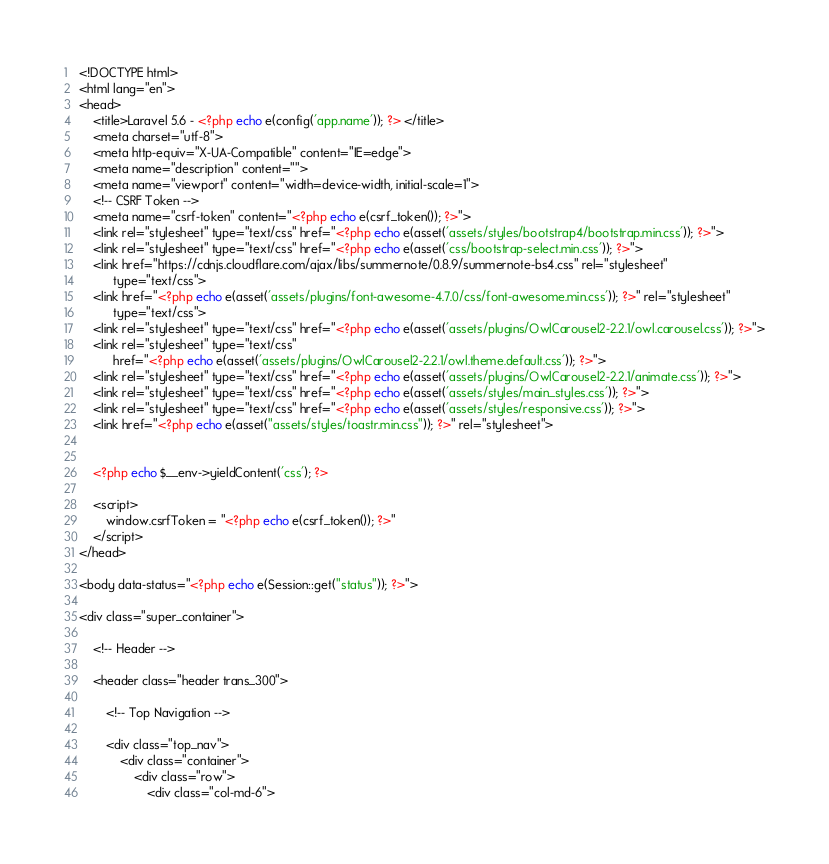<code> <loc_0><loc_0><loc_500><loc_500><_PHP_><!DOCTYPE html>
<html lang="en">
<head>
    <title>Laravel 5.6 - <?php echo e(config('app.name')); ?> </title>
    <meta charset="utf-8">
    <meta http-equiv="X-UA-Compatible" content="IE=edge">
    <meta name="description" content="">
    <meta name="viewport" content="width=device-width, initial-scale=1">
    <!-- CSRF Token -->
    <meta name="csrf-token" content="<?php echo e(csrf_token()); ?>">
    <link rel="stylesheet" type="text/css" href="<?php echo e(asset('assets/styles/bootstrap4/bootstrap.min.css')); ?>">
    <link rel="stylesheet" type="text/css" href="<?php echo e(asset('css/bootstrap-select.min.css')); ?>">
    <link href="https://cdnjs.cloudflare.com/ajax/libs/summernote/0.8.9/summernote-bs4.css" rel="stylesheet"
          type="text/css">
    <link href="<?php echo e(asset('assets/plugins/font-awesome-4.7.0/css/font-awesome.min.css')); ?>" rel="stylesheet"
          type="text/css">
    <link rel="stylesheet" type="text/css" href="<?php echo e(asset('assets/plugins/OwlCarousel2-2.2.1/owl.carousel.css')); ?>">
    <link rel="stylesheet" type="text/css"
          href="<?php echo e(asset('assets/plugins/OwlCarousel2-2.2.1/owl.theme.default.css')); ?>">
    <link rel="stylesheet" type="text/css" href="<?php echo e(asset('assets/plugins/OwlCarousel2-2.2.1/animate.css')); ?>">
    <link rel="stylesheet" type="text/css" href="<?php echo e(asset('assets/styles/main_styles.css')); ?>">
    <link rel="stylesheet" type="text/css" href="<?php echo e(asset('assets/styles/responsive.css')); ?>">
    <link href="<?php echo e(asset("assets/styles/toastr.min.css")); ?>" rel="stylesheet">


    <?php echo $__env->yieldContent('css'); ?>

    <script>
        window.csrfToken = "<?php echo e(csrf_token()); ?>"
    </script>
</head>

<body data-status="<?php echo e(Session::get("status")); ?>">

<div class="super_container">

    <!-- Header -->

    <header class="header trans_300">

        <!-- Top Navigation -->

        <div class="top_nav">
            <div class="container">
                <div class="row">
                    <div class="col-md-6"></code> 